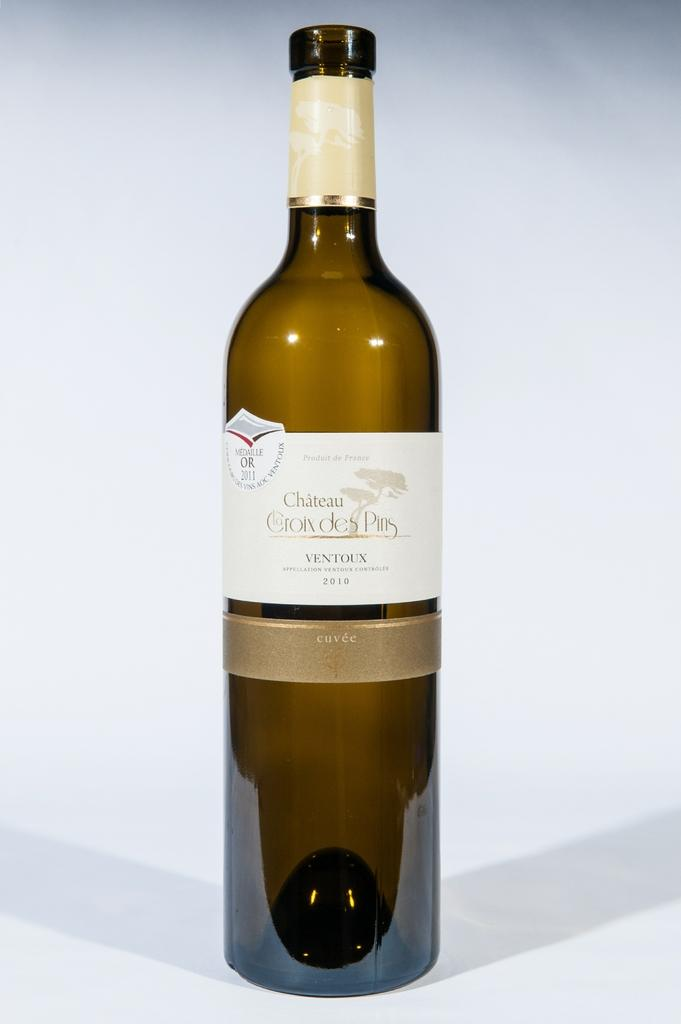<image>
Offer a succinct explanation of the picture presented. a bottle of chateau la croix des pins with a white label 